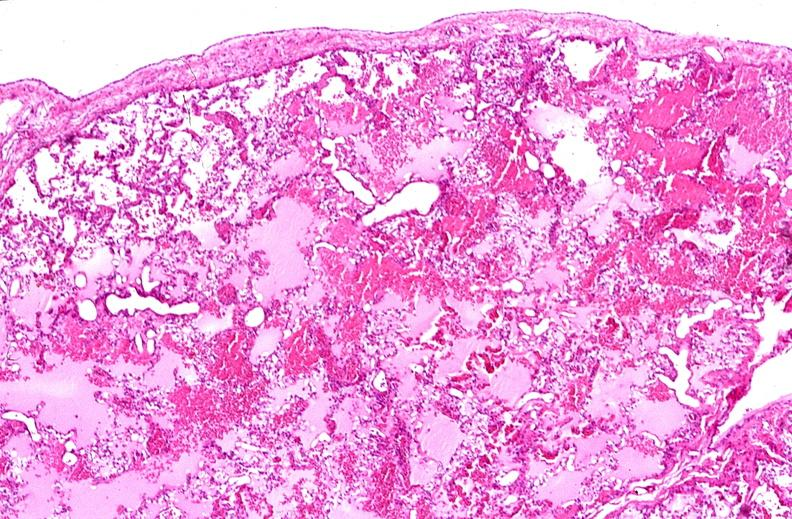why does this image show lung, pulmonary edema in patient with congestive heart failure?
Answer the question using a single word or phrase. Due to transplant rejection 